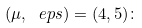<formula> <loc_0><loc_0><loc_500><loc_500>( \mu , \ e p s ) = ( 4 , 5 ) \colon</formula> 